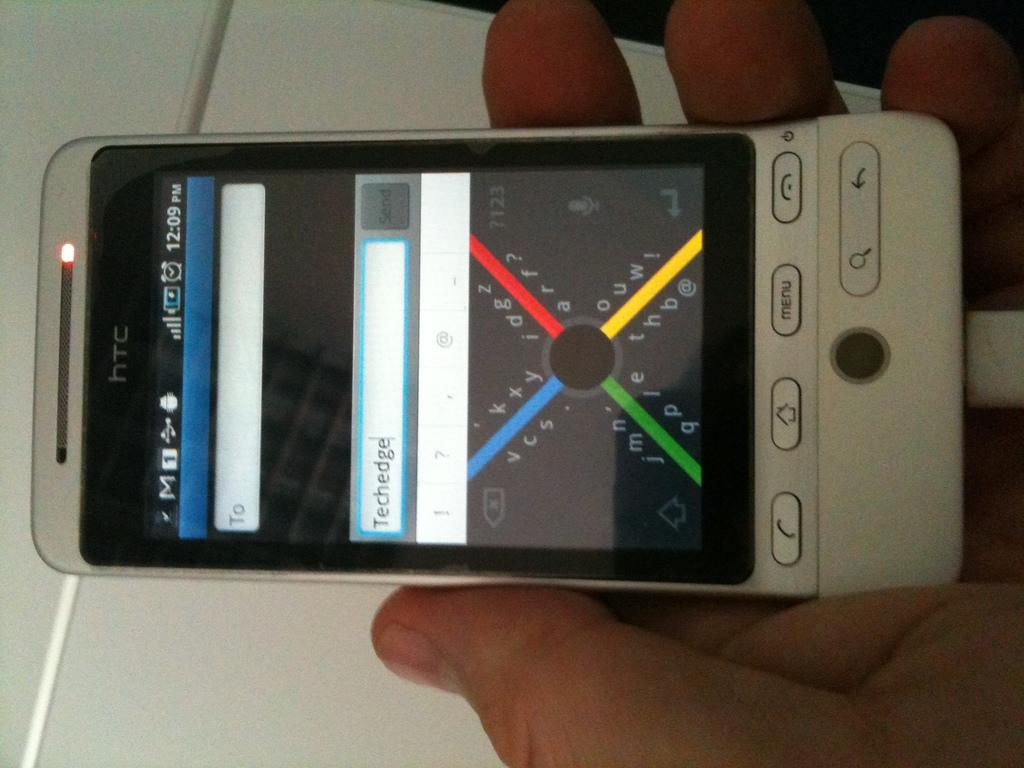<image>
Write a terse but informative summary of the picture. A htc smart phone being held by someone. 